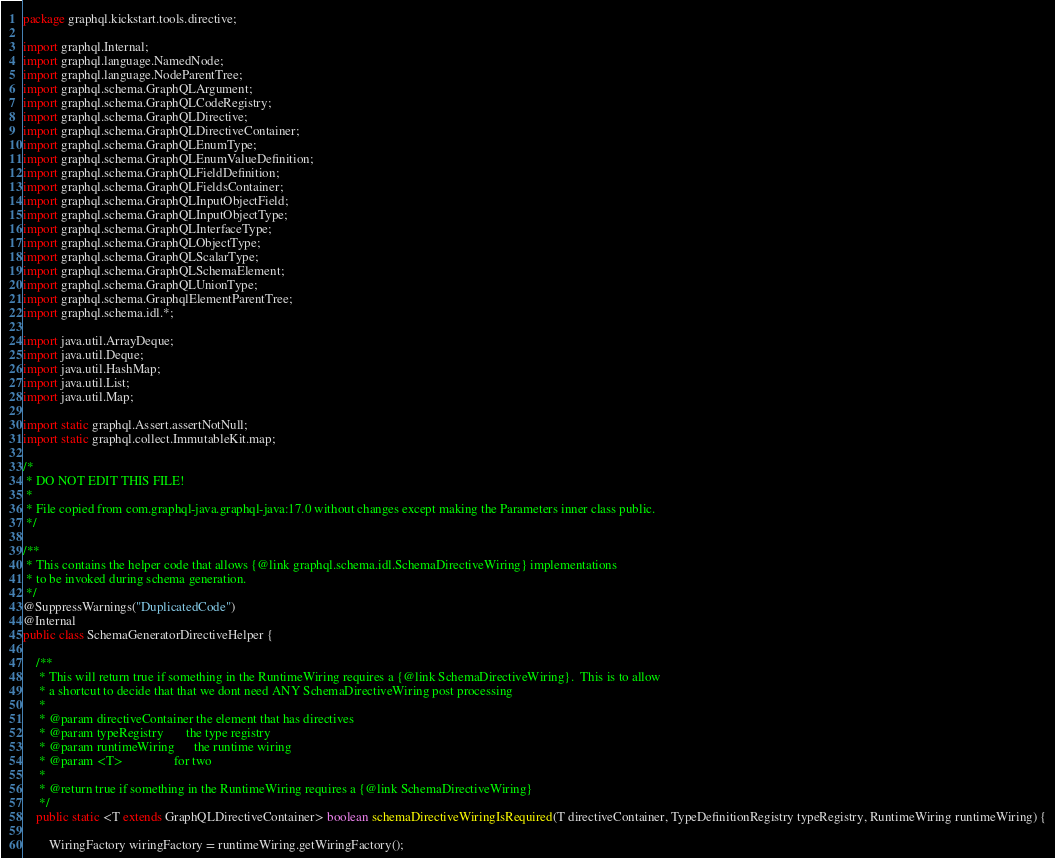Convert code to text. <code><loc_0><loc_0><loc_500><loc_500><_Java_>package graphql.kickstart.tools.directive;

import graphql.Internal;
import graphql.language.NamedNode;
import graphql.language.NodeParentTree;
import graphql.schema.GraphQLArgument;
import graphql.schema.GraphQLCodeRegistry;
import graphql.schema.GraphQLDirective;
import graphql.schema.GraphQLDirectiveContainer;
import graphql.schema.GraphQLEnumType;
import graphql.schema.GraphQLEnumValueDefinition;
import graphql.schema.GraphQLFieldDefinition;
import graphql.schema.GraphQLFieldsContainer;
import graphql.schema.GraphQLInputObjectField;
import graphql.schema.GraphQLInputObjectType;
import graphql.schema.GraphQLInterfaceType;
import graphql.schema.GraphQLObjectType;
import graphql.schema.GraphQLScalarType;
import graphql.schema.GraphQLSchemaElement;
import graphql.schema.GraphQLUnionType;
import graphql.schema.GraphqlElementParentTree;
import graphql.schema.idl.*;

import java.util.ArrayDeque;
import java.util.Deque;
import java.util.HashMap;
import java.util.List;
import java.util.Map;

import static graphql.Assert.assertNotNull;
import static graphql.collect.ImmutableKit.map;

/*
 * DO NOT EDIT THIS FILE!
 *
 * File copied from com.graphql-java.graphql-java:17.0 without changes except making the Parameters inner class public.
 */

/**
 * This contains the helper code that allows {@link graphql.schema.idl.SchemaDirectiveWiring} implementations
 * to be invoked during schema generation.
 */
@SuppressWarnings("DuplicatedCode")
@Internal
public class SchemaGeneratorDirectiveHelper {

    /**
     * This will return true if something in the RuntimeWiring requires a {@link SchemaDirectiveWiring}.  This is to allow
     * a shortcut to decide that that we dont need ANY SchemaDirectiveWiring post processing
     *
     * @param directiveContainer the element that has directives
     * @param typeRegistry       the type registry
     * @param runtimeWiring      the runtime wiring
     * @param <T>                for two
     *
     * @return true if something in the RuntimeWiring requires a {@link SchemaDirectiveWiring}
     */
    public static <T extends GraphQLDirectiveContainer> boolean schemaDirectiveWiringIsRequired(T directiveContainer, TypeDefinitionRegistry typeRegistry, RuntimeWiring runtimeWiring) {

        WiringFactory wiringFactory = runtimeWiring.getWiringFactory();
</code> 